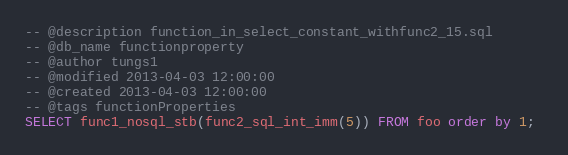<code> <loc_0><loc_0><loc_500><loc_500><_SQL_>-- @description function_in_select_constant_withfunc2_15.sql
-- @db_name functionproperty
-- @author tungs1
-- @modified 2013-04-03 12:00:00
-- @created 2013-04-03 12:00:00
-- @tags functionProperties 
SELECT func1_nosql_stb(func2_sql_int_imm(5)) FROM foo order by 1; 
</code> 